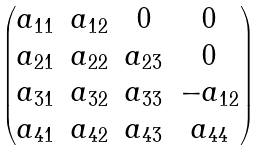<formula> <loc_0><loc_0><loc_500><loc_500>\begin{pmatrix} a _ { 1 1 } & a _ { 1 2 } & 0 & 0 \\ a _ { 2 1 } & a _ { 2 2 } & a _ { 2 3 } & 0 \\ a _ { 3 1 } & a _ { 3 2 } & a _ { 3 3 } & - a _ { 1 2 } \\ a _ { 4 1 } & a _ { 4 2 } & a _ { 4 3 } & a _ { 4 4 } \end{pmatrix}</formula> 